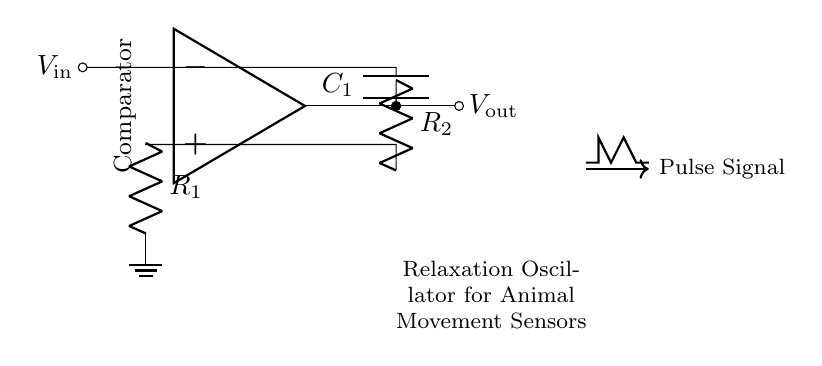What type of circuit is represented in the diagram? The diagram represents a relaxation oscillator, which is indicated by the components and their configuration, particularly the operational amplifier functioning as a comparator and its feedback components.
Answer: Relaxation oscillator What components are used in the circuit? The circuit contains a resistor R1, a resistor R2, a capacitor C1, and an operational amplifier. These components are essential for the circuit's function to create pulse signals.
Answer: R1, R2, C1, operational amplifier What is the output voltage represented as? The output voltage is denoted as V out, which is shown as a signal that results from the operation of the relaxation oscillator circuit.
Answer: V out What is the purpose of the operational amplifier in this circuit? The operational amplifier acts as a comparator. It compares the voltages at its inverting and non-inverting inputs to switch the output state, creating the oscillation necessary for pulse generation.
Answer: Comparator How does the capacitor C1 contribute to the functioning of the oscillator? The capacitor C1 charges and discharges through resistors R1 and R2, which helps in generating the timing for the pulse signal, thereby allowing the circuit to oscillate.
Answer: Timing What kind of signal does this circuit generate? The circuit generates a pulse signal, which is specifically indicated by the visual representation of the oscillation labeled as pulse signal in the diagram.
Answer: Pulse signal 